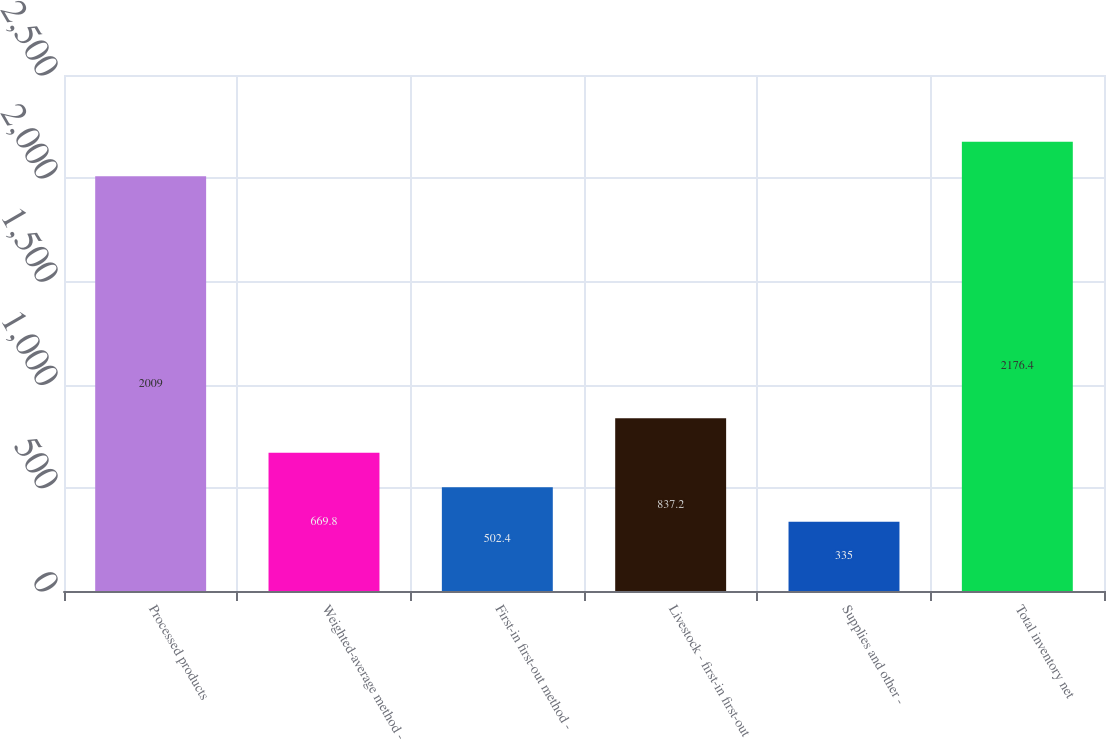Convert chart to OTSL. <chart><loc_0><loc_0><loc_500><loc_500><bar_chart><fcel>Processed products<fcel>Weighted-average method -<fcel>First-in first-out method -<fcel>Livestock - first-in first-out<fcel>Supplies and other -<fcel>Total inventory net<nl><fcel>2009<fcel>669.8<fcel>502.4<fcel>837.2<fcel>335<fcel>2176.4<nl></chart> 